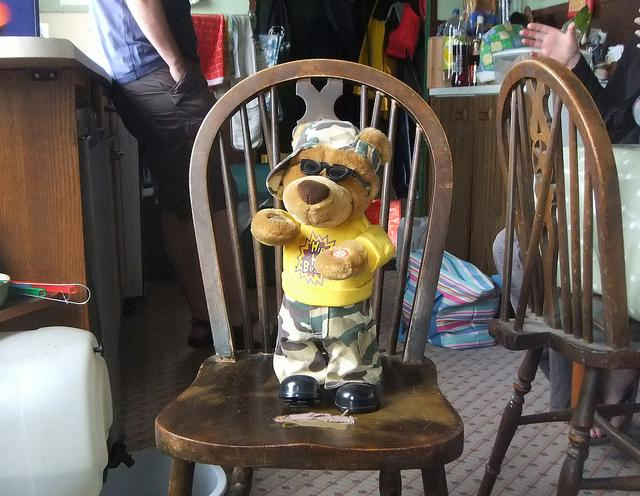What style of pants are these? camo 